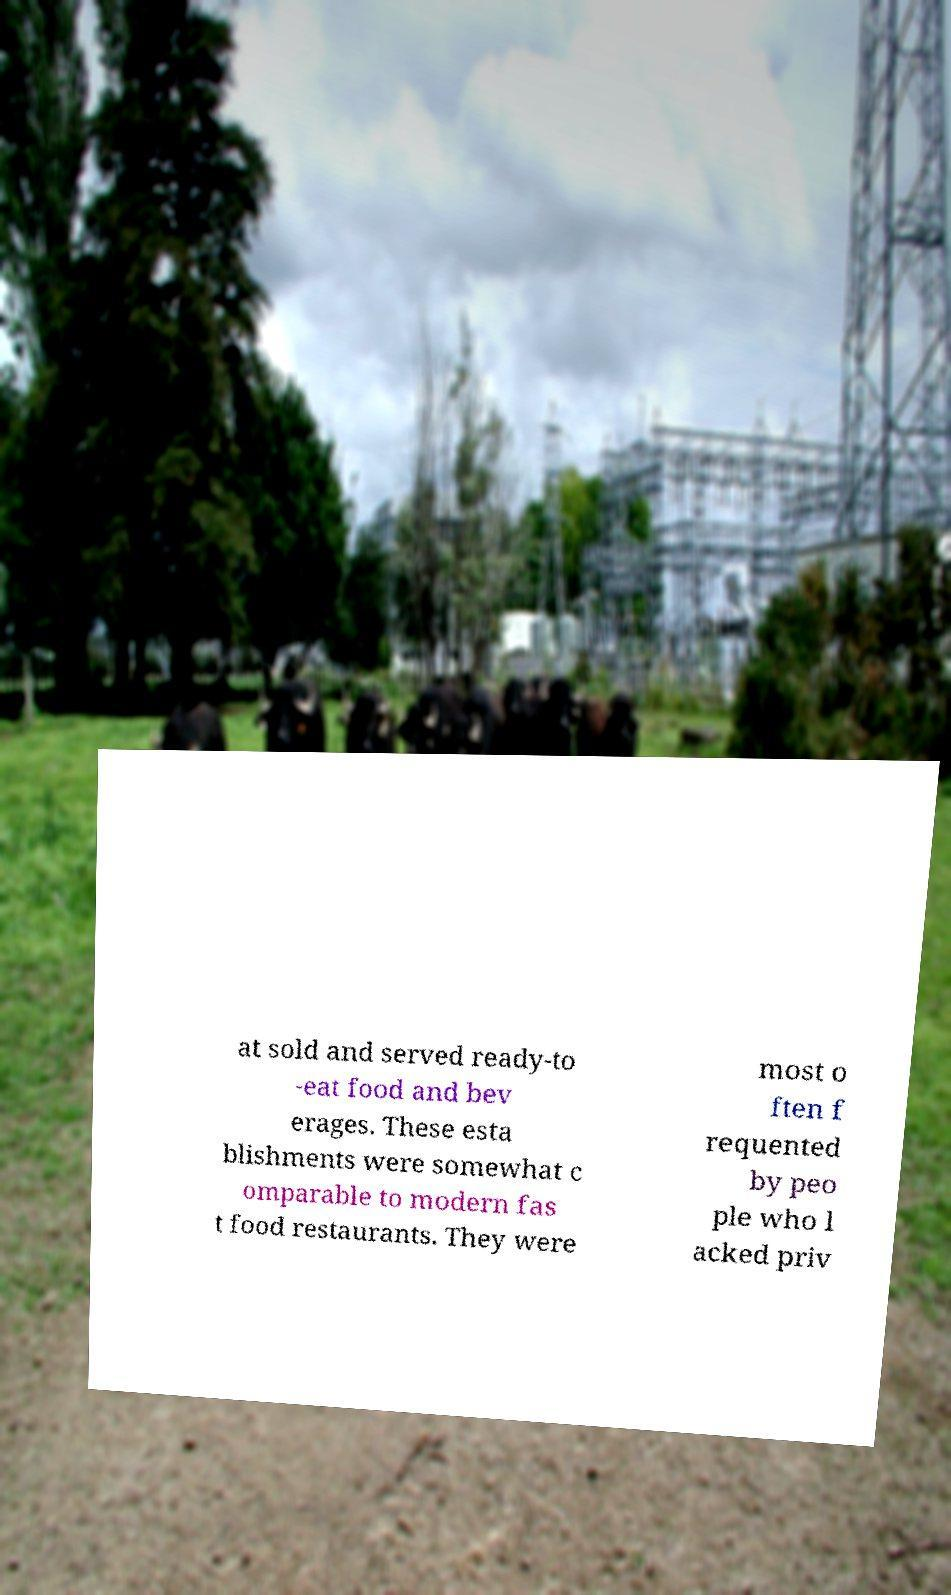For documentation purposes, I need the text within this image transcribed. Could you provide that? at sold and served ready-to -eat food and bev erages. These esta blishments were somewhat c omparable to modern fas t food restaurants. They were most o ften f requented by peo ple who l acked priv 